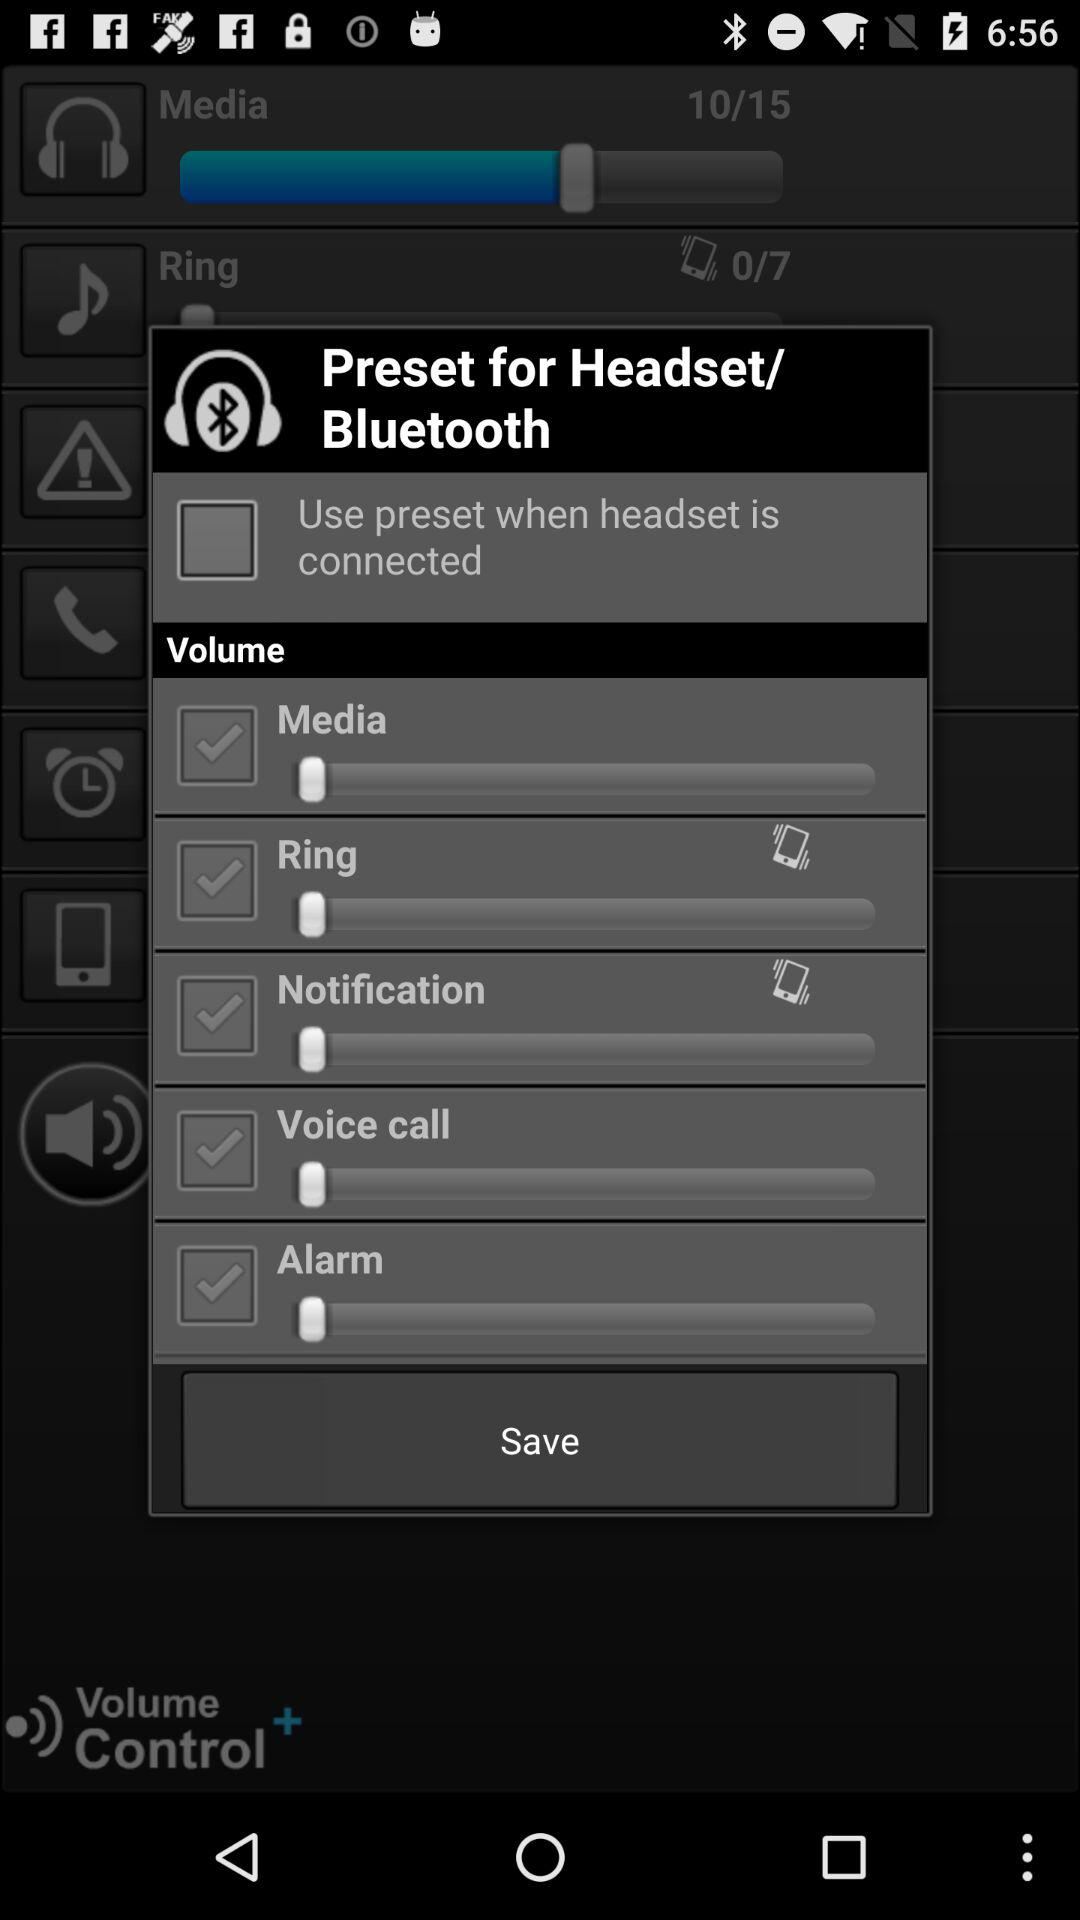What is the status of the "Use preset when headset is connected"? The status is "off". 